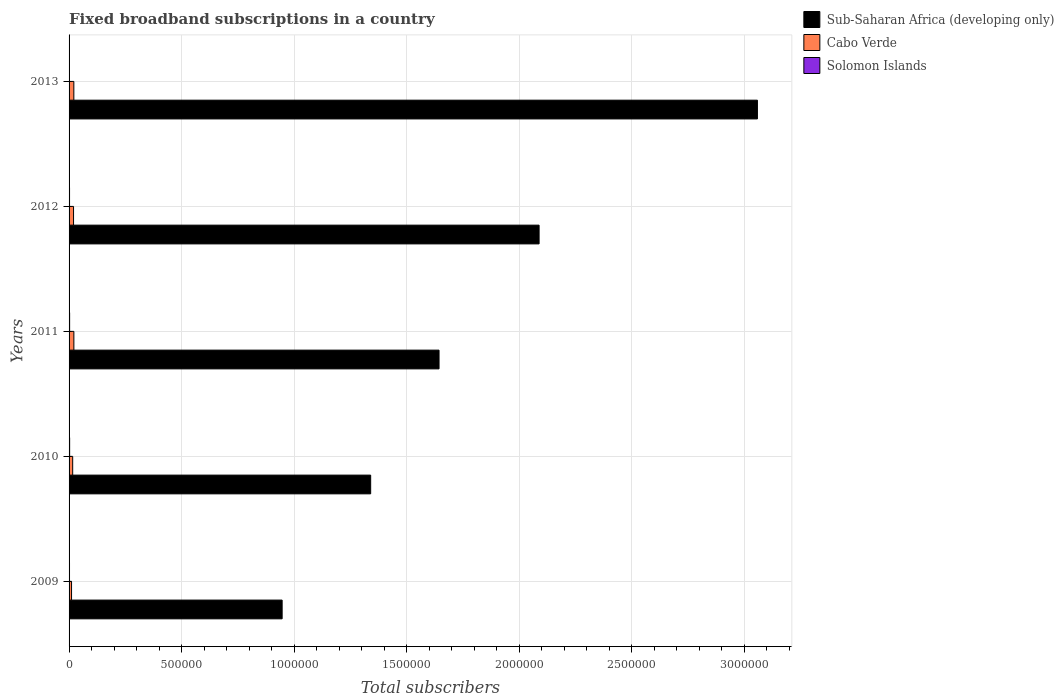Are the number of bars on each tick of the Y-axis equal?
Ensure brevity in your answer.  Yes. How many bars are there on the 3rd tick from the bottom?
Ensure brevity in your answer.  3. What is the label of the 2nd group of bars from the top?
Offer a very short reply. 2012. What is the number of broadband subscriptions in Sub-Saharan Africa (developing only) in 2010?
Provide a succinct answer. 1.34e+06. Across all years, what is the maximum number of broadband subscriptions in Solomon Islands?
Provide a short and direct response. 2522. Across all years, what is the minimum number of broadband subscriptions in Sub-Saharan Africa (developing only)?
Provide a succinct answer. 9.47e+05. In which year was the number of broadband subscriptions in Solomon Islands maximum?
Keep it short and to the point. 2010. In which year was the number of broadband subscriptions in Cabo Verde minimum?
Keep it short and to the point. 2009. What is the total number of broadband subscriptions in Sub-Saharan Africa (developing only) in the graph?
Your answer should be very brief. 9.08e+06. What is the difference between the number of broadband subscriptions in Solomon Islands in 2010 and that in 2011?
Your response must be concise. 92. What is the difference between the number of broadband subscriptions in Solomon Islands in 2010 and the number of broadband subscriptions in Sub-Saharan Africa (developing only) in 2009?
Make the answer very short. -9.44e+05. What is the average number of broadband subscriptions in Sub-Saharan Africa (developing only) per year?
Give a very brief answer. 1.82e+06. In the year 2013, what is the difference between the number of broadband subscriptions in Cabo Verde and number of broadband subscriptions in Solomon Islands?
Make the answer very short. 1.93e+04. In how many years, is the number of broadband subscriptions in Cabo Verde greater than 700000 ?
Keep it short and to the point. 0. What is the ratio of the number of broadband subscriptions in Sub-Saharan Africa (developing only) in 2009 to that in 2013?
Offer a very short reply. 0.31. Is the number of broadband subscriptions in Cabo Verde in 2011 less than that in 2013?
Keep it short and to the point. No. What is the difference between the highest and the second highest number of broadband subscriptions in Cabo Verde?
Give a very brief answer. 120. What is the difference between the highest and the lowest number of broadband subscriptions in Sub-Saharan Africa (developing only)?
Keep it short and to the point. 2.11e+06. What does the 1st bar from the top in 2010 represents?
Your answer should be compact. Solomon Islands. What does the 3rd bar from the bottom in 2009 represents?
Make the answer very short. Solomon Islands. Is it the case that in every year, the sum of the number of broadband subscriptions in Cabo Verde and number of broadband subscriptions in Sub-Saharan Africa (developing only) is greater than the number of broadband subscriptions in Solomon Islands?
Provide a short and direct response. Yes. How many bars are there?
Provide a succinct answer. 15. Are all the bars in the graph horizontal?
Offer a terse response. Yes. Are the values on the major ticks of X-axis written in scientific E-notation?
Provide a short and direct response. No. Where does the legend appear in the graph?
Your answer should be compact. Top right. How are the legend labels stacked?
Your response must be concise. Vertical. What is the title of the graph?
Give a very brief answer. Fixed broadband subscriptions in a country. What is the label or title of the X-axis?
Provide a succinct answer. Total subscribers. What is the Total subscribers in Sub-Saharan Africa (developing only) in 2009?
Offer a very short reply. 9.47e+05. What is the Total subscribers of Cabo Verde in 2009?
Offer a very short reply. 1.10e+04. What is the Total subscribers of Sub-Saharan Africa (developing only) in 2010?
Make the answer very short. 1.34e+06. What is the Total subscribers in Cabo Verde in 2010?
Provide a short and direct response. 1.61e+04. What is the Total subscribers of Solomon Islands in 2010?
Provide a succinct answer. 2522. What is the Total subscribers in Sub-Saharan Africa (developing only) in 2011?
Your answer should be very brief. 1.64e+06. What is the Total subscribers in Cabo Verde in 2011?
Provide a short and direct response. 2.13e+04. What is the Total subscribers in Solomon Islands in 2011?
Offer a terse response. 2430. What is the Total subscribers in Sub-Saharan Africa (developing only) in 2012?
Your answer should be compact. 2.09e+06. What is the Total subscribers in Cabo Verde in 2012?
Your response must be concise. 1.99e+04. What is the Total subscribers in Solomon Islands in 2012?
Offer a terse response. 2132. What is the Total subscribers in Sub-Saharan Africa (developing only) in 2013?
Your response must be concise. 3.06e+06. What is the Total subscribers in Cabo Verde in 2013?
Provide a short and direct response. 2.12e+04. What is the Total subscribers of Solomon Islands in 2013?
Ensure brevity in your answer.  1884. Across all years, what is the maximum Total subscribers of Sub-Saharan Africa (developing only)?
Give a very brief answer. 3.06e+06. Across all years, what is the maximum Total subscribers of Cabo Verde?
Your response must be concise. 2.13e+04. Across all years, what is the maximum Total subscribers in Solomon Islands?
Your response must be concise. 2522. Across all years, what is the minimum Total subscribers in Sub-Saharan Africa (developing only)?
Provide a succinct answer. 9.47e+05. Across all years, what is the minimum Total subscribers in Cabo Verde?
Keep it short and to the point. 1.10e+04. Across all years, what is the minimum Total subscribers of Solomon Islands?
Provide a short and direct response. 1884. What is the total Total subscribers in Sub-Saharan Africa (developing only) in the graph?
Ensure brevity in your answer.  9.08e+06. What is the total Total subscribers in Cabo Verde in the graph?
Your response must be concise. 8.94e+04. What is the total Total subscribers in Solomon Islands in the graph?
Your answer should be compact. 1.10e+04. What is the difference between the Total subscribers of Sub-Saharan Africa (developing only) in 2009 and that in 2010?
Give a very brief answer. -3.93e+05. What is the difference between the Total subscribers of Cabo Verde in 2009 and that in 2010?
Your answer should be compact. -5099. What is the difference between the Total subscribers of Solomon Islands in 2009 and that in 2010?
Give a very brief answer. -522. What is the difference between the Total subscribers in Sub-Saharan Africa (developing only) in 2009 and that in 2011?
Ensure brevity in your answer.  -6.97e+05. What is the difference between the Total subscribers of Cabo Verde in 2009 and that in 2011?
Offer a terse response. -1.04e+04. What is the difference between the Total subscribers of Solomon Islands in 2009 and that in 2011?
Give a very brief answer. -430. What is the difference between the Total subscribers of Sub-Saharan Africa (developing only) in 2009 and that in 2012?
Offer a very short reply. -1.14e+06. What is the difference between the Total subscribers of Cabo Verde in 2009 and that in 2012?
Provide a short and direct response. -8881. What is the difference between the Total subscribers of Solomon Islands in 2009 and that in 2012?
Keep it short and to the point. -132. What is the difference between the Total subscribers in Sub-Saharan Africa (developing only) in 2009 and that in 2013?
Your answer should be very brief. -2.11e+06. What is the difference between the Total subscribers in Cabo Verde in 2009 and that in 2013?
Your answer should be compact. -1.02e+04. What is the difference between the Total subscribers in Solomon Islands in 2009 and that in 2013?
Offer a very short reply. 116. What is the difference between the Total subscribers of Sub-Saharan Africa (developing only) in 2010 and that in 2011?
Offer a very short reply. -3.04e+05. What is the difference between the Total subscribers of Cabo Verde in 2010 and that in 2011?
Offer a very short reply. -5261. What is the difference between the Total subscribers in Solomon Islands in 2010 and that in 2011?
Offer a very short reply. 92. What is the difference between the Total subscribers of Sub-Saharan Africa (developing only) in 2010 and that in 2012?
Make the answer very short. -7.48e+05. What is the difference between the Total subscribers in Cabo Verde in 2010 and that in 2012?
Your answer should be very brief. -3782. What is the difference between the Total subscribers in Solomon Islands in 2010 and that in 2012?
Provide a short and direct response. 390. What is the difference between the Total subscribers of Sub-Saharan Africa (developing only) in 2010 and that in 2013?
Make the answer very short. -1.72e+06. What is the difference between the Total subscribers of Cabo Verde in 2010 and that in 2013?
Ensure brevity in your answer.  -5141. What is the difference between the Total subscribers in Solomon Islands in 2010 and that in 2013?
Make the answer very short. 638. What is the difference between the Total subscribers of Sub-Saharan Africa (developing only) in 2011 and that in 2012?
Your answer should be compact. -4.44e+05. What is the difference between the Total subscribers of Cabo Verde in 2011 and that in 2012?
Keep it short and to the point. 1479. What is the difference between the Total subscribers of Solomon Islands in 2011 and that in 2012?
Your response must be concise. 298. What is the difference between the Total subscribers in Sub-Saharan Africa (developing only) in 2011 and that in 2013?
Provide a short and direct response. -1.41e+06. What is the difference between the Total subscribers in Cabo Verde in 2011 and that in 2013?
Give a very brief answer. 120. What is the difference between the Total subscribers of Solomon Islands in 2011 and that in 2013?
Provide a short and direct response. 546. What is the difference between the Total subscribers in Sub-Saharan Africa (developing only) in 2012 and that in 2013?
Make the answer very short. -9.70e+05. What is the difference between the Total subscribers in Cabo Verde in 2012 and that in 2013?
Your answer should be compact. -1359. What is the difference between the Total subscribers in Solomon Islands in 2012 and that in 2013?
Your answer should be very brief. 248. What is the difference between the Total subscribers of Sub-Saharan Africa (developing only) in 2009 and the Total subscribers of Cabo Verde in 2010?
Your response must be concise. 9.30e+05. What is the difference between the Total subscribers in Sub-Saharan Africa (developing only) in 2009 and the Total subscribers in Solomon Islands in 2010?
Give a very brief answer. 9.44e+05. What is the difference between the Total subscribers in Cabo Verde in 2009 and the Total subscribers in Solomon Islands in 2010?
Offer a terse response. 8450. What is the difference between the Total subscribers in Sub-Saharan Africa (developing only) in 2009 and the Total subscribers in Cabo Verde in 2011?
Offer a very short reply. 9.25e+05. What is the difference between the Total subscribers of Sub-Saharan Africa (developing only) in 2009 and the Total subscribers of Solomon Islands in 2011?
Give a very brief answer. 9.44e+05. What is the difference between the Total subscribers of Cabo Verde in 2009 and the Total subscribers of Solomon Islands in 2011?
Provide a succinct answer. 8542. What is the difference between the Total subscribers in Sub-Saharan Africa (developing only) in 2009 and the Total subscribers in Cabo Verde in 2012?
Your response must be concise. 9.27e+05. What is the difference between the Total subscribers of Sub-Saharan Africa (developing only) in 2009 and the Total subscribers of Solomon Islands in 2012?
Give a very brief answer. 9.44e+05. What is the difference between the Total subscribers in Cabo Verde in 2009 and the Total subscribers in Solomon Islands in 2012?
Your answer should be compact. 8840. What is the difference between the Total subscribers in Sub-Saharan Africa (developing only) in 2009 and the Total subscribers in Cabo Verde in 2013?
Your answer should be compact. 9.25e+05. What is the difference between the Total subscribers in Sub-Saharan Africa (developing only) in 2009 and the Total subscribers in Solomon Islands in 2013?
Provide a succinct answer. 9.45e+05. What is the difference between the Total subscribers of Cabo Verde in 2009 and the Total subscribers of Solomon Islands in 2013?
Your response must be concise. 9088. What is the difference between the Total subscribers of Sub-Saharan Africa (developing only) in 2010 and the Total subscribers of Cabo Verde in 2011?
Offer a terse response. 1.32e+06. What is the difference between the Total subscribers in Sub-Saharan Africa (developing only) in 2010 and the Total subscribers in Solomon Islands in 2011?
Your answer should be very brief. 1.34e+06. What is the difference between the Total subscribers in Cabo Verde in 2010 and the Total subscribers in Solomon Islands in 2011?
Your response must be concise. 1.36e+04. What is the difference between the Total subscribers of Sub-Saharan Africa (developing only) in 2010 and the Total subscribers of Cabo Verde in 2012?
Give a very brief answer. 1.32e+06. What is the difference between the Total subscribers in Sub-Saharan Africa (developing only) in 2010 and the Total subscribers in Solomon Islands in 2012?
Your answer should be very brief. 1.34e+06. What is the difference between the Total subscribers in Cabo Verde in 2010 and the Total subscribers in Solomon Islands in 2012?
Ensure brevity in your answer.  1.39e+04. What is the difference between the Total subscribers of Sub-Saharan Africa (developing only) in 2010 and the Total subscribers of Cabo Verde in 2013?
Ensure brevity in your answer.  1.32e+06. What is the difference between the Total subscribers in Sub-Saharan Africa (developing only) in 2010 and the Total subscribers in Solomon Islands in 2013?
Make the answer very short. 1.34e+06. What is the difference between the Total subscribers in Cabo Verde in 2010 and the Total subscribers in Solomon Islands in 2013?
Offer a very short reply. 1.42e+04. What is the difference between the Total subscribers of Sub-Saharan Africa (developing only) in 2011 and the Total subscribers of Cabo Verde in 2012?
Ensure brevity in your answer.  1.62e+06. What is the difference between the Total subscribers of Sub-Saharan Africa (developing only) in 2011 and the Total subscribers of Solomon Islands in 2012?
Keep it short and to the point. 1.64e+06. What is the difference between the Total subscribers of Cabo Verde in 2011 and the Total subscribers of Solomon Islands in 2012?
Make the answer very short. 1.92e+04. What is the difference between the Total subscribers of Sub-Saharan Africa (developing only) in 2011 and the Total subscribers of Cabo Verde in 2013?
Provide a short and direct response. 1.62e+06. What is the difference between the Total subscribers in Sub-Saharan Africa (developing only) in 2011 and the Total subscribers in Solomon Islands in 2013?
Make the answer very short. 1.64e+06. What is the difference between the Total subscribers in Cabo Verde in 2011 and the Total subscribers in Solomon Islands in 2013?
Your answer should be compact. 1.94e+04. What is the difference between the Total subscribers in Sub-Saharan Africa (developing only) in 2012 and the Total subscribers in Cabo Verde in 2013?
Your answer should be very brief. 2.07e+06. What is the difference between the Total subscribers in Sub-Saharan Africa (developing only) in 2012 and the Total subscribers in Solomon Islands in 2013?
Offer a terse response. 2.09e+06. What is the difference between the Total subscribers in Cabo Verde in 2012 and the Total subscribers in Solomon Islands in 2013?
Offer a terse response. 1.80e+04. What is the average Total subscribers of Sub-Saharan Africa (developing only) per year?
Keep it short and to the point. 1.82e+06. What is the average Total subscribers in Cabo Verde per year?
Make the answer very short. 1.79e+04. What is the average Total subscribers of Solomon Islands per year?
Your answer should be very brief. 2193.6. In the year 2009, what is the difference between the Total subscribers in Sub-Saharan Africa (developing only) and Total subscribers in Cabo Verde?
Your answer should be very brief. 9.36e+05. In the year 2009, what is the difference between the Total subscribers in Sub-Saharan Africa (developing only) and Total subscribers in Solomon Islands?
Give a very brief answer. 9.45e+05. In the year 2009, what is the difference between the Total subscribers of Cabo Verde and Total subscribers of Solomon Islands?
Ensure brevity in your answer.  8972. In the year 2010, what is the difference between the Total subscribers of Sub-Saharan Africa (developing only) and Total subscribers of Cabo Verde?
Offer a terse response. 1.32e+06. In the year 2010, what is the difference between the Total subscribers of Sub-Saharan Africa (developing only) and Total subscribers of Solomon Islands?
Your answer should be compact. 1.34e+06. In the year 2010, what is the difference between the Total subscribers of Cabo Verde and Total subscribers of Solomon Islands?
Provide a succinct answer. 1.35e+04. In the year 2011, what is the difference between the Total subscribers of Sub-Saharan Africa (developing only) and Total subscribers of Cabo Verde?
Make the answer very short. 1.62e+06. In the year 2011, what is the difference between the Total subscribers in Sub-Saharan Africa (developing only) and Total subscribers in Solomon Islands?
Your answer should be very brief. 1.64e+06. In the year 2011, what is the difference between the Total subscribers in Cabo Verde and Total subscribers in Solomon Islands?
Provide a short and direct response. 1.89e+04. In the year 2012, what is the difference between the Total subscribers of Sub-Saharan Africa (developing only) and Total subscribers of Cabo Verde?
Provide a short and direct response. 2.07e+06. In the year 2012, what is the difference between the Total subscribers of Sub-Saharan Africa (developing only) and Total subscribers of Solomon Islands?
Give a very brief answer. 2.09e+06. In the year 2012, what is the difference between the Total subscribers in Cabo Verde and Total subscribers in Solomon Islands?
Provide a short and direct response. 1.77e+04. In the year 2013, what is the difference between the Total subscribers in Sub-Saharan Africa (developing only) and Total subscribers in Cabo Verde?
Ensure brevity in your answer.  3.04e+06. In the year 2013, what is the difference between the Total subscribers in Sub-Saharan Africa (developing only) and Total subscribers in Solomon Islands?
Offer a very short reply. 3.06e+06. In the year 2013, what is the difference between the Total subscribers of Cabo Verde and Total subscribers of Solomon Islands?
Your response must be concise. 1.93e+04. What is the ratio of the Total subscribers of Sub-Saharan Africa (developing only) in 2009 to that in 2010?
Ensure brevity in your answer.  0.71. What is the ratio of the Total subscribers of Cabo Verde in 2009 to that in 2010?
Your answer should be very brief. 0.68. What is the ratio of the Total subscribers in Solomon Islands in 2009 to that in 2010?
Ensure brevity in your answer.  0.79. What is the ratio of the Total subscribers in Sub-Saharan Africa (developing only) in 2009 to that in 2011?
Keep it short and to the point. 0.58. What is the ratio of the Total subscribers in Cabo Verde in 2009 to that in 2011?
Offer a very short reply. 0.51. What is the ratio of the Total subscribers in Solomon Islands in 2009 to that in 2011?
Your response must be concise. 0.82. What is the ratio of the Total subscribers in Sub-Saharan Africa (developing only) in 2009 to that in 2012?
Offer a very short reply. 0.45. What is the ratio of the Total subscribers in Cabo Verde in 2009 to that in 2012?
Offer a very short reply. 0.55. What is the ratio of the Total subscribers in Solomon Islands in 2009 to that in 2012?
Provide a succinct answer. 0.94. What is the ratio of the Total subscribers in Sub-Saharan Africa (developing only) in 2009 to that in 2013?
Make the answer very short. 0.31. What is the ratio of the Total subscribers of Cabo Verde in 2009 to that in 2013?
Offer a terse response. 0.52. What is the ratio of the Total subscribers in Solomon Islands in 2009 to that in 2013?
Provide a succinct answer. 1.06. What is the ratio of the Total subscribers in Sub-Saharan Africa (developing only) in 2010 to that in 2011?
Keep it short and to the point. 0.82. What is the ratio of the Total subscribers in Cabo Verde in 2010 to that in 2011?
Provide a succinct answer. 0.75. What is the ratio of the Total subscribers of Solomon Islands in 2010 to that in 2011?
Your response must be concise. 1.04. What is the ratio of the Total subscribers in Sub-Saharan Africa (developing only) in 2010 to that in 2012?
Give a very brief answer. 0.64. What is the ratio of the Total subscribers in Cabo Verde in 2010 to that in 2012?
Provide a succinct answer. 0.81. What is the ratio of the Total subscribers in Solomon Islands in 2010 to that in 2012?
Your response must be concise. 1.18. What is the ratio of the Total subscribers in Sub-Saharan Africa (developing only) in 2010 to that in 2013?
Offer a very short reply. 0.44. What is the ratio of the Total subscribers of Cabo Verde in 2010 to that in 2013?
Your response must be concise. 0.76. What is the ratio of the Total subscribers of Solomon Islands in 2010 to that in 2013?
Your response must be concise. 1.34. What is the ratio of the Total subscribers of Sub-Saharan Africa (developing only) in 2011 to that in 2012?
Keep it short and to the point. 0.79. What is the ratio of the Total subscribers of Cabo Verde in 2011 to that in 2012?
Your answer should be compact. 1.07. What is the ratio of the Total subscribers of Solomon Islands in 2011 to that in 2012?
Offer a very short reply. 1.14. What is the ratio of the Total subscribers in Sub-Saharan Africa (developing only) in 2011 to that in 2013?
Ensure brevity in your answer.  0.54. What is the ratio of the Total subscribers of Solomon Islands in 2011 to that in 2013?
Ensure brevity in your answer.  1.29. What is the ratio of the Total subscribers in Sub-Saharan Africa (developing only) in 2012 to that in 2013?
Your response must be concise. 0.68. What is the ratio of the Total subscribers in Cabo Verde in 2012 to that in 2013?
Your answer should be compact. 0.94. What is the ratio of the Total subscribers of Solomon Islands in 2012 to that in 2013?
Keep it short and to the point. 1.13. What is the difference between the highest and the second highest Total subscribers in Sub-Saharan Africa (developing only)?
Provide a short and direct response. 9.70e+05. What is the difference between the highest and the second highest Total subscribers of Cabo Verde?
Offer a terse response. 120. What is the difference between the highest and the second highest Total subscribers of Solomon Islands?
Ensure brevity in your answer.  92. What is the difference between the highest and the lowest Total subscribers in Sub-Saharan Africa (developing only)?
Offer a very short reply. 2.11e+06. What is the difference between the highest and the lowest Total subscribers of Cabo Verde?
Your answer should be compact. 1.04e+04. What is the difference between the highest and the lowest Total subscribers in Solomon Islands?
Your answer should be very brief. 638. 